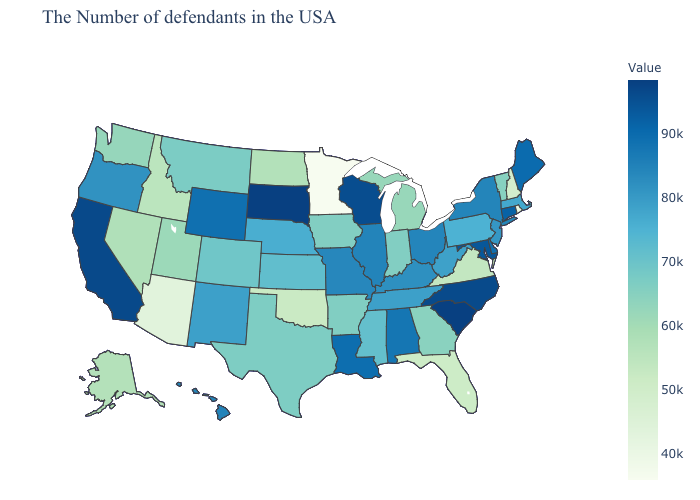Does the map have missing data?
Write a very short answer. No. Which states have the lowest value in the USA?
Keep it brief. Minnesota. Which states have the lowest value in the West?
Be succinct. Arizona. Among the states that border Arkansas , does Mississippi have the highest value?
Give a very brief answer. No. Which states have the lowest value in the USA?
Give a very brief answer. Minnesota. Which states have the lowest value in the South?
Give a very brief answer. Florida. Which states have the highest value in the USA?
Quick response, please. South Carolina, South Dakota. 